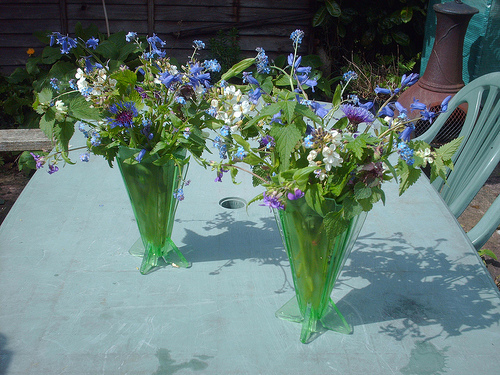Please provide a short description for this region: [0.33, 0.54, 0.59, 0.71]. The shadow of a vase full of blooming flowers projects onto the sunlit blue table surface, creating an interesting interplay of light and dark. 